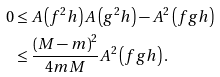Convert formula to latex. <formula><loc_0><loc_0><loc_500><loc_500>0 & \leq A \left ( f ^ { 2 } h \right ) A \left ( g ^ { 2 } h \right ) - A ^ { 2 } \left ( f g h \right ) \\ & \leq \frac { \left ( M - m \right ) ^ { 2 } } { 4 m M } A ^ { 2 } \left ( f g h \right ) .</formula> 